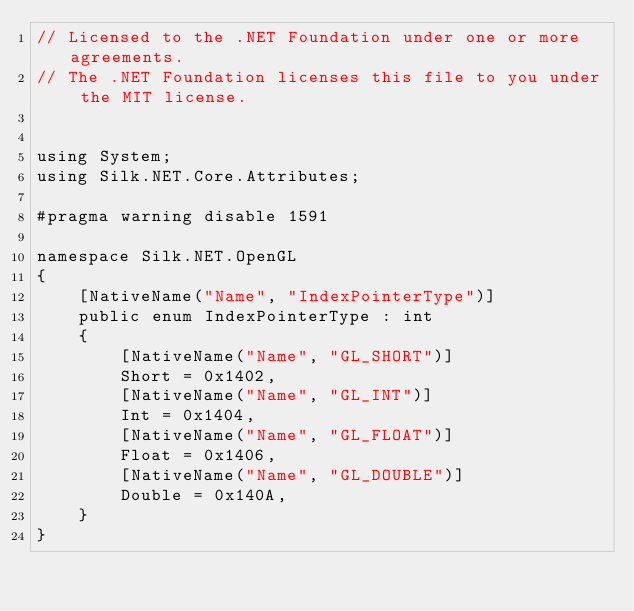Convert code to text. <code><loc_0><loc_0><loc_500><loc_500><_C#_>// Licensed to the .NET Foundation under one or more agreements.
// The .NET Foundation licenses this file to you under the MIT license.


using System;
using Silk.NET.Core.Attributes;

#pragma warning disable 1591

namespace Silk.NET.OpenGL
{
    [NativeName("Name", "IndexPointerType")]
    public enum IndexPointerType : int
    {
        [NativeName("Name", "GL_SHORT")]
        Short = 0x1402,
        [NativeName("Name", "GL_INT")]
        Int = 0x1404,
        [NativeName("Name", "GL_FLOAT")]
        Float = 0x1406,
        [NativeName("Name", "GL_DOUBLE")]
        Double = 0x140A,
    }
}
</code> 